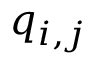Convert formula to latex. <formula><loc_0><loc_0><loc_500><loc_500>q _ { i , j }</formula> 